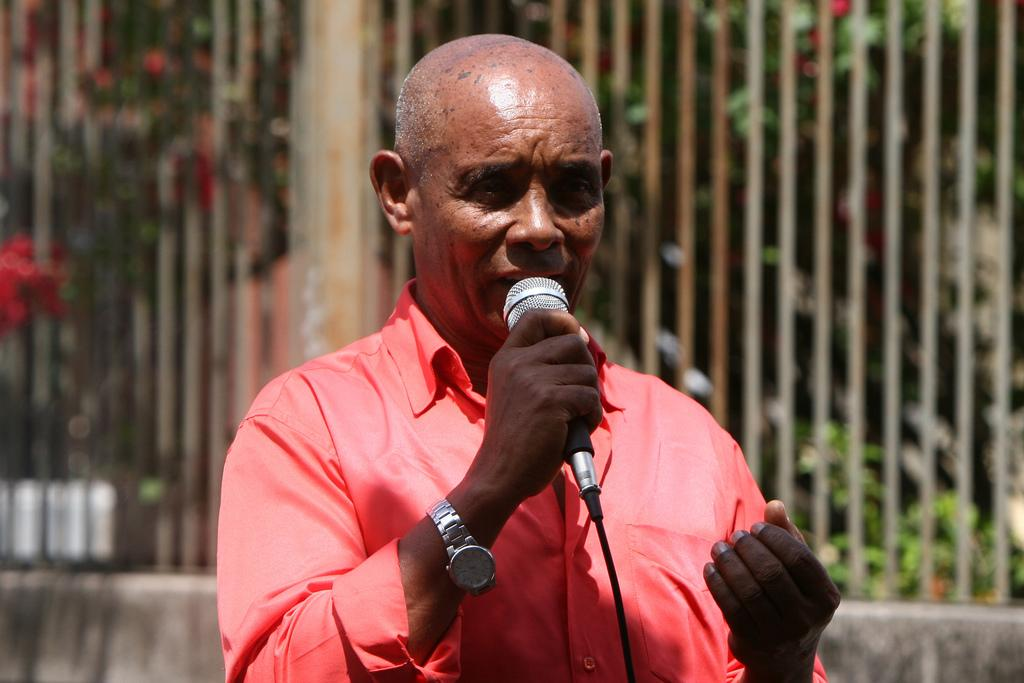What is the man in the image doing? The man is standing in the image and speaking. What is the man holding in his hand? The man is holding a microphone in his hand. What can be seen in the background of the image? There is fencing visible in the background of the image. What type of patch is the man wearing on his shirt in the image? There is no patch visible on the man's shirt in the image. What is the man thinking while holding the microphone in the image? The image does not provide information about the man's thoughts, so we cannot determine what he is thinking. 